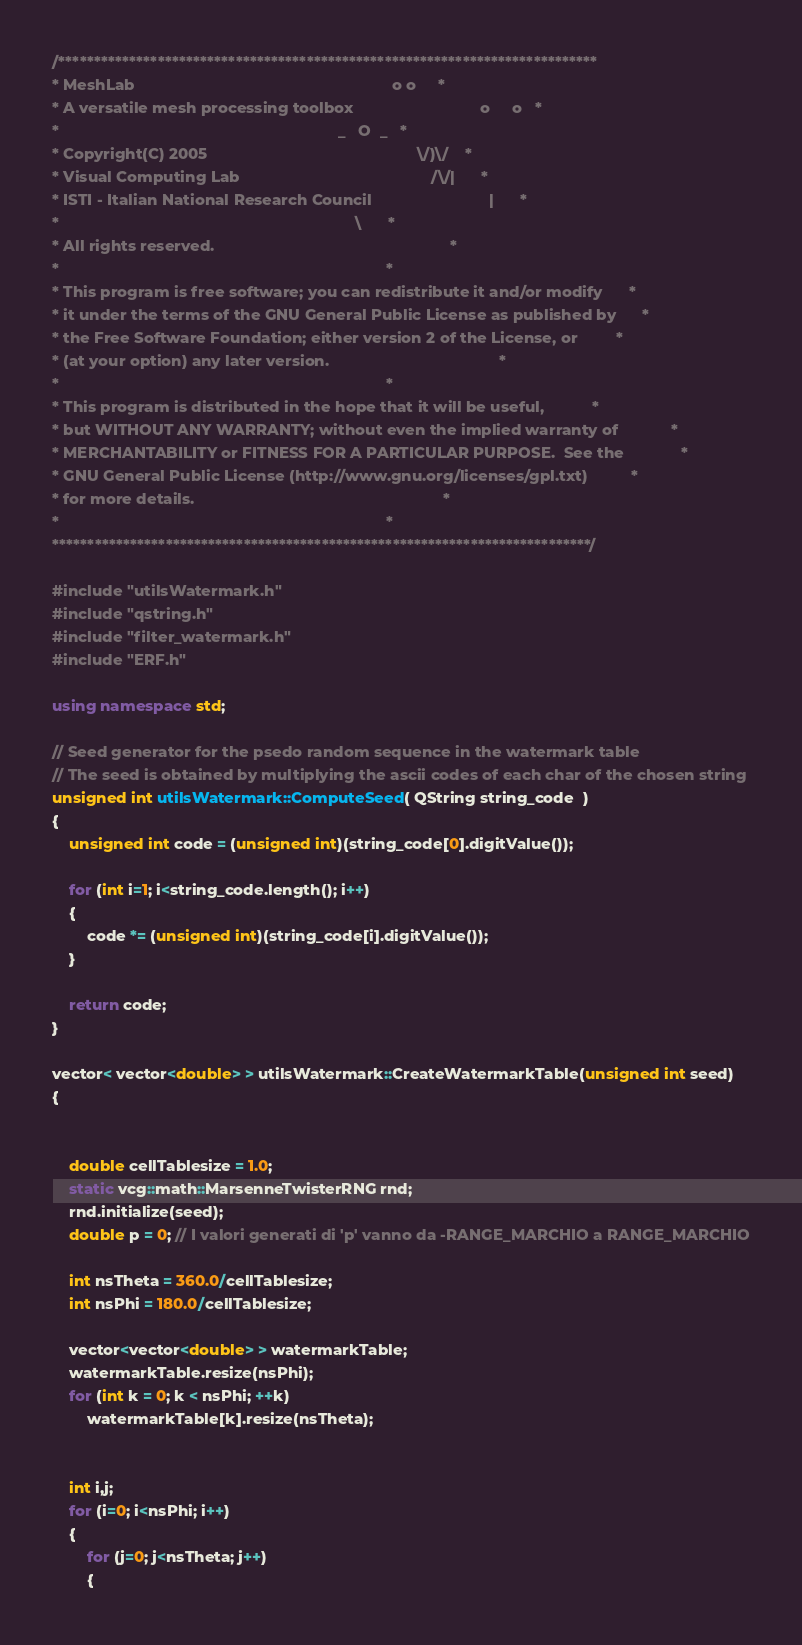<code> <loc_0><loc_0><loc_500><loc_500><_C++_>/****************************************************************************
* MeshLab                                                           o o     *
* A versatile mesh processing toolbox                             o     o   *
*                                                                _   O  _   *
* Copyright(C) 2005                                                \/)\/    *
* Visual Computing Lab                                            /\/|      *
* ISTI - Italian National Research Council                           |      *
*                                                                    \      *
* All rights reserved.                                                      *
*                                                                           *
* This program is free software; you can redistribute it and/or modify      *
* it under the terms of the GNU General Public License as published by      *
* the Free Software Foundation; either version 2 of the License, or         *
* (at your option) any later version.                                       *
*                                                                           *
* This program is distributed in the hope that it will be useful,           *
* but WITHOUT ANY WARRANTY; without even the implied warranty of            *
* MERCHANTABILITY or FITNESS FOR A PARTICULAR PURPOSE.  See the             *
* GNU General Public License (http://www.gnu.org/licenses/gpl.txt)          *
* for more details.                                                         *
*                                                                           *
****************************************************************************/

#include "utilsWatermark.h"
#include "qstring.h"
#include "filter_watermark.h"
#include "ERF.h"

using namespace std;

// Seed generator for the psedo random sequence in the watermark table 
// The seed is obtained by multiplying the ascii codes of each char of the chosen string
unsigned int utilsWatermark::ComputeSeed( QString string_code  )
{
	unsigned int code = (unsigned int)(string_code[0].digitValue());

	for (int i=1; i<string_code.length(); i++)
	{
		code *= (unsigned int)(string_code[i].digitValue());
	}

	return code;
}

vector< vector<double> > utilsWatermark::CreateWatermarkTable(unsigned int seed)
{
	
	
	double cellTablesize = 1.0;
	static vcg::math::MarsenneTwisterRNG rnd;
	rnd.initialize(seed);
	double p = 0; // I valori generati di 'p' vanno da -RANGE_MARCHIO a RANGE_MARCHIO

	int nsTheta = 360.0/cellTablesize;
	int nsPhi = 180.0/cellTablesize;

	vector<vector<double> > watermarkTable;
	watermarkTable.resize(nsPhi);
	for (int k = 0; k < nsPhi; ++k)
	    watermarkTable[k].resize(nsTheta);


	int i,j;
	for (i=0; i<nsPhi; i++)
	{
		for (j=0; j<nsTheta; j++)
		{</code> 